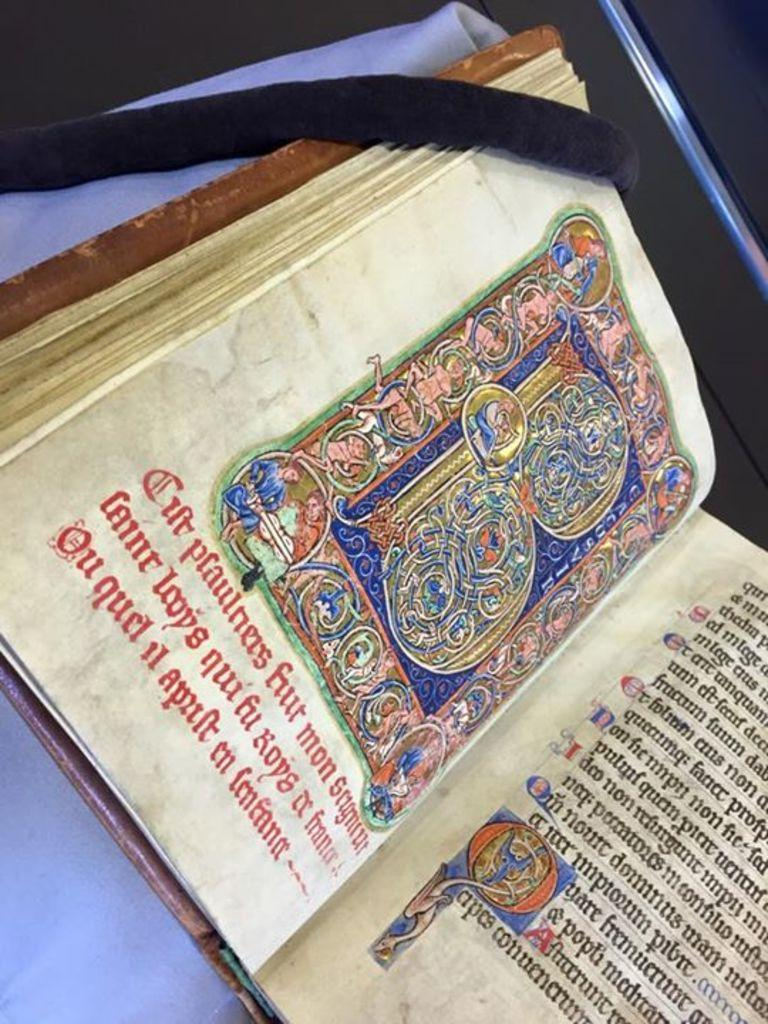Provide a one-sentence caption for the provided image. An old manuscript book open on an ornate letter B with the word mon in the text. 